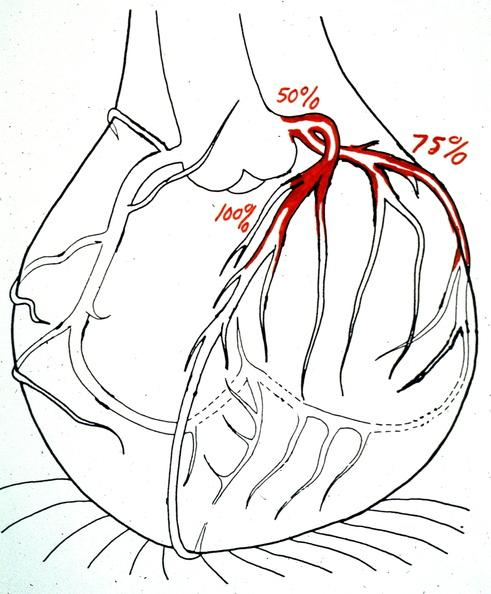what does this image show?
Answer the question using a single word or phrase. Heart 